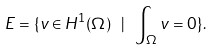Convert formula to latex. <formula><loc_0><loc_0><loc_500><loc_500>E = \{ v \in H ^ { 1 } ( \Omega ) \ | \ \int _ { \Omega } v = 0 \} .</formula> 